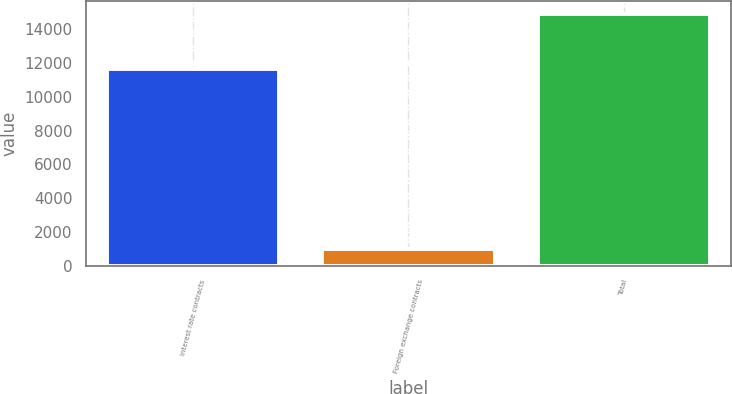<chart> <loc_0><loc_0><loc_500><loc_500><bar_chart><fcel>Interest rate contracts<fcel>Foreign exchange contracts<fcel>Total<nl><fcel>11621<fcel>969<fcel>14904<nl></chart> 